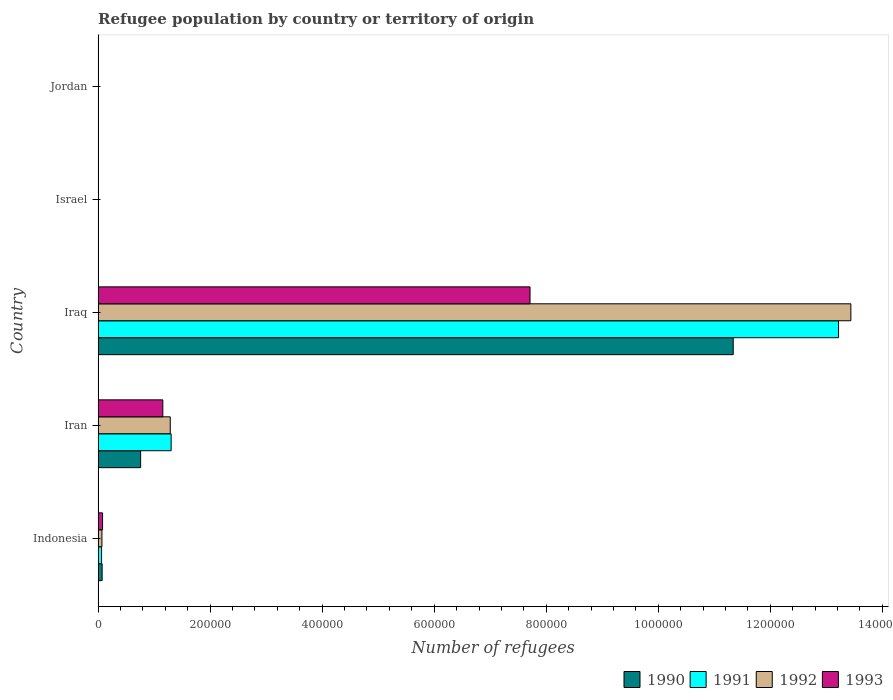How many groups of bars are there?
Offer a very short reply. 5. Are the number of bars per tick equal to the number of legend labels?
Provide a succinct answer. Yes. Are the number of bars on each tick of the Y-axis equal?
Provide a succinct answer. Yes. How many bars are there on the 3rd tick from the bottom?
Provide a short and direct response. 4. What is the label of the 2nd group of bars from the top?
Make the answer very short. Israel. What is the number of refugees in 1993 in Iraq?
Give a very brief answer. 7.71e+05. Across all countries, what is the maximum number of refugees in 1992?
Keep it short and to the point. 1.34e+06. Across all countries, what is the minimum number of refugees in 1990?
Make the answer very short. 16. In which country was the number of refugees in 1990 maximum?
Provide a short and direct response. Iraq. In which country was the number of refugees in 1990 minimum?
Offer a terse response. Israel. What is the total number of refugees in 1993 in the graph?
Your answer should be compact. 8.95e+05. What is the difference between the number of refugees in 1993 in Indonesia and that in Israel?
Provide a succinct answer. 7806. What is the difference between the number of refugees in 1991 in Jordan and the number of refugees in 1990 in Indonesia?
Ensure brevity in your answer.  -7057. What is the average number of refugees in 1992 per country?
Give a very brief answer. 2.96e+05. What is the difference between the number of refugees in 1992 and number of refugees in 1991 in Indonesia?
Ensure brevity in your answer.  665. In how many countries, is the number of refugees in 1992 greater than 360000 ?
Offer a very short reply. 1. What is the ratio of the number of refugees in 1993 in Israel to that in Jordan?
Your response must be concise. 0.49. Is the difference between the number of refugees in 1992 in Iran and Iraq greater than the difference between the number of refugees in 1991 in Iran and Iraq?
Ensure brevity in your answer.  No. What is the difference between the highest and the second highest number of refugees in 1990?
Offer a terse response. 1.06e+06. What is the difference between the highest and the lowest number of refugees in 1993?
Offer a terse response. 7.71e+05. Is the sum of the number of refugees in 1991 in Iraq and Israel greater than the maximum number of refugees in 1993 across all countries?
Your response must be concise. Yes. What does the 2nd bar from the top in Indonesia represents?
Keep it short and to the point. 1992. What does the 2nd bar from the bottom in Iran represents?
Offer a terse response. 1991. How many bars are there?
Offer a terse response. 20. Are all the bars in the graph horizontal?
Your answer should be compact. Yes. What is the difference between two consecutive major ticks on the X-axis?
Offer a very short reply. 2.00e+05. Are the values on the major ticks of X-axis written in scientific E-notation?
Give a very brief answer. No. How many legend labels are there?
Your response must be concise. 4. How are the legend labels stacked?
Offer a terse response. Horizontal. What is the title of the graph?
Offer a very short reply. Refugee population by country or territory of origin. What is the label or title of the X-axis?
Offer a terse response. Number of refugees. What is the label or title of the Y-axis?
Offer a terse response. Country. What is the Number of refugees in 1990 in Indonesia?
Provide a short and direct response. 7169. What is the Number of refugees of 1991 in Indonesia?
Keep it short and to the point. 6164. What is the Number of refugees in 1992 in Indonesia?
Make the answer very short. 6829. What is the Number of refugees in 1993 in Indonesia?
Your answer should be compact. 7924. What is the Number of refugees of 1990 in Iran?
Make the answer very short. 7.59e+04. What is the Number of refugees in 1991 in Iran?
Provide a succinct answer. 1.30e+05. What is the Number of refugees in 1992 in Iran?
Make the answer very short. 1.29e+05. What is the Number of refugees of 1993 in Iran?
Your answer should be compact. 1.16e+05. What is the Number of refugees of 1990 in Iraq?
Ensure brevity in your answer.  1.13e+06. What is the Number of refugees in 1991 in Iraq?
Make the answer very short. 1.32e+06. What is the Number of refugees of 1992 in Iraq?
Provide a short and direct response. 1.34e+06. What is the Number of refugees in 1993 in Iraq?
Offer a very short reply. 7.71e+05. What is the Number of refugees of 1990 in Israel?
Provide a short and direct response. 16. What is the Number of refugees of 1991 in Israel?
Your response must be concise. 28. What is the Number of refugees in 1993 in Israel?
Offer a terse response. 118. What is the Number of refugees of 1990 in Jordan?
Offer a terse response. 55. What is the Number of refugees in 1991 in Jordan?
Make the answer very short. 112. What is the Number of refugees of 1992 in Jordan?
Offer a very short reply. 183. What is the Number of refugees of 1993 in Jordan?
Provide a succinct answer. 242. Across all countries, what is the maximum Number of refugees in 1990?
Give a very brief answer. 1.13e+06. Across all countries, what is the maximum Number of refugees in 1991?
Provide a short and direct response. 1.32e+06. Across all countries, what is the maximum Number of refugees of 1992?
Your answer should be compact. 1.34e+06. Across all countries, what is the maximum Number of refugees of 1993?
Make the answer very short. 7.71e+05. Across all countries, what is the minimum Number of refugees in 1993?
Offer a very short reply. 118. What is the total Number of refugees in 1990 in the graph?
Your answer should be compact. 1.22e+06. What is the total Number of refugees of 1991 in the graph?
Keep it short and to the point. 1.46e+06. What is the total Number of refugees of 1992 in the graph?
Your answer should be compact. 1.48e+06. What is the total Number of refugees in 1993 in the graph?
Your response must be concise. 8.95e+05. What is the difference between the Number of refugees of 1990 in Indonesia and that in Iran?
Provide a succinct answer. -6.87e+04. What is the difference between the Number of refugees in 1991 in Indonesia and that in Iran?
Your answer should be compact. -1.24e+05. What is the difference between the Number of refugees in 1992 in Indonesia and that in Iran?
Your answer should be very brief. -1.22e+05. What is the difference between the Number of refugees in 1993 in Indonesia and that in Iran?
Keep it short and to the point. -1.08e+05. What is the difference between the Number of refugees of 1990 in Indonesia and that in Iraq?
Offer a very short reply. -1.13e+06. What is the difference between the Number of refugees of 1991 in Indonesia and that in Iraq?
Offer a terse response. -1.32e+06. What is the difference between the Number of refugees of 1992 in Indonesia and that in Iraq?
Offer a very short reply. -1.34e+06. What is the difference between the Number of refugees in 1993 in Indonesia and that in Iraq?
Your answer should be very brief. -7.63e+05. What is the difference between the Number of refugees in 1990 in Indonesia and that in Israel?
Provide a short and direct response. 7153. What is the difference between the Number of refugees of 1991 in Indonesia and that in Israel?
Your answer should be very brief. 6136. What is the difference between the Number of refugees of 1992 in Indonesia and that in Israel?
Offer a very short reply. 6789. What is the difference between the Number of refugees in 1993 in Indonesia and that in Israel?
Your answer should be compact. 7806. What is the difference between the Number of refugees of 1990 in Indonesia and that in Jordan?
Offer a terse response. 7114. What is the difference between the Number of refugees in 1991 in Indonesia and that in Jordan?
Offer a terse response. 6052. What is the difference between the Number of refugees of 1992 in Indonesia and that in Jordan?
Provide a succinct answer. 6646. What is the difference between the Number of refugees of 1993 in Indonesia and that in Jordan?
Keep it short and to the point. 7682. What is the difference between the Number of refugees of 1990 in Iran and that in Iraq?
Make the answer very short. -1.06e+06. What is the difference between the Number of refugees of 1991 in Iran and that in Iraq?
Provide a succinct answer. -1.19e+06. What is the difference between the Number of refugees in 1992 in Iran and that in Iraq?
Your response must be concise. -1.22e+06. What is the difference between the Number of refugees in 1993 in Iran and that in Iraq?
Offer a terse response. -6.56e+05. What is the difference between the Number of refugees in 1990 in Iran and that in Israel?
Your answer should be compact. 7.59e+04. What is the difference between the Number of refugees in 1991 in Iran and that in Israel?
Make the answer very short. 1.30e+05. What is the difference between the Number of refugees in 1992 in Iran and that in Israel?
Keep it short and to the point. 1.29e+05. What is the difference between the Number of refugees in 1993 in Iran and that in Israel?
Give a very brief answer. 1.15e+05. What is the difference between the Number of refugees of 1990 in Iran and that in Jordan?
Your answer should be very brief. 7.58e+04. What is the difference between the Number of refugees in 1991 in Iran and that in Jordan?
Ensure brevity in your answer.  1.30e+05. What is the difference between the Number of refugees of 1992 in Iran and that in Jordan?
Ensure brevity in your answer.  1.29e+05. What is the difference between the Number of refugees of 1993 in Iran and that in Jordan?
Keep it short and to the point. 1.15e+05. What is the difference between the Number of refugees in 1990 in Iraq and that in Israel?
Your response must be concise. 1.13e+06. What is the difference between the Number of refugees in 1991 in Iraq and that in Israel?
Your answer should be very brief. 1.32e+06. What is the difference between the Number of refugees in 1992 in Iraq and that in Israel?
Provide a succinct answer. 1.34e+06. What is the difference between the Number of refugees in 1993 in Iraq and that in Israel?
Your answer should be compact. 7.71e+05. What is the difference between the Number of refugees in 1990 in Iraq and that in Jordan?
Ensure brevity in your answer.  1.13e+06. What is the difference between the Number of refugees of 1991 in Iraq and that in Jordan?
Keep it short and to the point. 1.32e+06. What is the difference between the Number of refugees in 1992 in Iraq and that in Jordan?
Ensure brevity in your answer.  1.34e+06. What is the difference between the Number of refugees of 1993 in Iraq and that in Jordan?
Your answer should be very brief. 7.71e+05. What is the difference between the Number of refugees in 1990 in Israel and that in Jordan?
Keep it short and to the point. -39. What is the difference between the Number of refugees in 1991 in Israel and that in Jordan?
Provide a succinct answer. -84. What is the difference between the Number of refugees in 1992 in Israel and that in Jordan?
Provide a short and direct response. -143. What is the difference between the Number of refugees in 1993 in Israel and that in Jordan?
Your response must be concise. -124. What is the difference between the Number of refugees of 1990 in Indonesia and the Number of refugees of 1991 in Iran?
Offer a very short reply. -1.23e+05. What is the difference between the Number of refugees in 1990 in Indonesia and the Number of refugees in 1992 in Iran?
Provide a short and direct response. -1.22e+05. What is the difference between the Number of refugees in 1990 in Indonesia and the Number of refugees in 1993 in Iran?
Your answer should be very brief. -1.08e+05. What is the difference between the Number of refugees of 1991 in Indonesia and the Number of refugees of 1992 in Iran?
Give a very brief answer. -1.23e+05. What is the difference between the Number of refugees of 1991 in Indonesia and the Number of refugees of 1993 in Iran?
Offer a very short reply. -1.09e+05. What is the difference between the Number of refugees in 1992 in Indonesia and the Number of refugees in 1993 in Iran?
Keep it short and to the point. -1.09e+05. What is the difference between the Number of refugees in 1990 in Indonesia and the Number of refugees in 1991 in Iraq?
Keep it short and to the point. -1.31e+06. What is the difference between the Number of refugees of 1990 in Indonesia and the Number of refugees of 1992 in Iraq?
Offer a terse response. -1.34e+06. What is the difference between the Number of refugees of 1990 in Indonesia and the Number of refugees of 1993 in Iraq?
Offer a very short reply. -7.64e+05. What is the difference between the Number of refugees of 1991 in Indonesia and the Number of refugees of 1992 in Iraq?
Offer a very short reply. -1.34e+06. What is the difference between the Number of refugees of 1991 in Indonesia and the Number of refugees of 1993 in Iraq?
Offer a terse response. -7.65e+05. What is the difference between the Number of refugees of 1992 in Indonesia and the Number of refugees of 1993 in Iraq?
Make the answer very short. -7.64e+05. What is the difference between the Number of refugees in 1990 in Indonesia and the Number of refugees in 1991 in Israel?
Your answer should be very brief. 7141. What is the difference between the Number of refugees in 1990 in Indonesia and the Number of refugees in 1992 in Israel?
Ensure brevity in your answer.  7129. What is the difference between the Number of refugees of 1990 in Indonesia and the Number of refugees of 1993 in Israel?
Keep it short and to the point. 7051. What is the difference between the Number of refugees of 1991 in Indonesia and the Number of refugees of 1992 in Israel?
Provide a succinct answer. 6124. What is the difference between the Number of refugees in 1991 in Indonesia and the Number of refugees in 1993 in Israel?
Provide a short and direct response. 6046. What is the difference between the Number of refugees of 1992 in Indonesia and the Number of refugees of 1993 in Israel?
Ensure brevity in your answer.  6711. What is the difference between the Number of refugees of 1990 in Indonesia and the Number of refugees of 1991 in Jordan?
Provide a short and direct response. 7057. What is the difference between the Number of refugees of 1990 in Indonesia and the Number of refugees of 1992 in Jordan?
Keep it short and to the point. 6986. What is the difference between the Number of refugees of 1990 in Indonesia and the Number of refugees of 1993 in Jordan?
Your answer should be compact. 6927. What is the difference between the Number of refugees in 1991 in Indonesia and the Number of refugees in 1992 in Jordan?
Give a very brief answer. 5981. What is the difference between the Number of refugees of 1991 in Indonesia and the Number of refugees of 1993 in Jordan?
Make the answer very short. 5922. What is the difference between the Number of refugees in 1992 in Indonesia and the Number of refugees in 1993 in Jordan?
Give a very brief answer. 6587. What is the difference between the Number of refugees in 1990 in Iran and the Number of refugees in 1991 in Iraq?
Your answer should be compact. -1.25e+06. What is the difference between the Number of refugees of 1990 in Iran and the Number of refugees of 1992 in Iraq?
Provide a succinct answer. -1.27e+06. What is the difference between the Number of refugees of 1990 in Iran and the Number of refugees of 1993 in Iraq?
Offer a very short reply. -6.95e+05. What is the difference between the Number of refugees in 1991 in Iran and the Number of refugees in 1992 in Iraq?
Provide a short and direct response. -1.21e+06. What is the difference between the Number of refugees in 1991 in Iran and the Number of refugees in 1993 in Iraq?
Provide a succinct answer. -6.41e+05. What is the difference between the Number of refugees in 1992 in Iran and the Number of refugees in 1993 in Iraq?
Provide a succinct answer. -6.42e+05. What is the difference between the Number of refugees in 1990 in Iran and the Number of refugees in 1991 in Israel?
Ensure brevity in your answer.  7.59e+04. What is the difference between the Number of refugees of 1990 in Iran and the Number of refugees of 1992 in Israel?
Your answer should be very brief. 7.58e+04. What is the difference between the Number of refugees of 1990 in Iran and the Number of refugees of 1993 in Israel?
Ensure brevity in your answer.  7.58e+04. What is the difference between the Number of refugees in 1991 in Iran and the Number of refugees in 1992 in Israel?
Your response must be concise. 1.30e+05. What is the difference between the Number of refugees of 1991 in Iran and the Number of refugees of 1993 in Israel?
Ensure brevity in your answer.  1.30e+05. What is the difference between the Number of refugees of 1992 in Iran and the Number of refugees of 1993 in Israel?
Your answer should be compact. 1.29e+05. What is the difference between the Number of refugees in 1990 in Iran and the Number of refugees in 1991 in Jordan?
Give a very brief answer. 7.58e+04. What is the difference between the Number of refugees of 1990 in Iran and the Number of refugees of 1992 in Jordan?
Keep it short and to the point. 7.57e+04. What is the difference between the Number of refugees of 1990 in Iran and the Number of refugees of 1993 in Jordan?
Keep it short and to the point. 7.56e+04. What is the difference between the Number of refugees of 1991 in Iran and the Number of refugees of 1992 in Jordan?
Give a very brief answer. 1.30e+05. What is the difference between the Number of refugees in 1991 in Iran and the Number of refugees in 1993 in Jordan?
Keep it short and to the point. 1.30e+05. What is the difference between the Number of refugees of 1992 in Iran and the Number of refugees of 1993 in Jordan?
Give a very brief answer. 1.29e+05. What is the difference between the Number of refugees in 1990 in Iraq and the Number of refugees in 1991 in Israel?
Provide a short and direct response. 1.13e+06. What is the difference between the Number of refugees in 1990 in Iraq and the Number of refugees in 1992 in Israel?
Your answer should be very brief. 1.13e+06. What is the difference between the Number of refugees in 1990 in Iraq and the Number of refugees in 1993 in Israel?
Make the answer very short. 1.13e+06. What is the difference between the Number of refugees of 1991 in Iraq and the Number of refugees of 1992 in Israel?
Your response must be concise. 1.32e+06. What is the difference between the Number of refugees of 1991 in Iraq and the Number of refugees of 1993 in Israel?
Offer a terse response. 1.32e+06. What is the difference between the Number of refugees of 1992 in Iraq and the Number of refugees of 1993 in Israel?
Make the answer very short. 1.34e+06. What is the difference between the Number of refugees in 1990 in Iraq and the Number of refugees in 1991 in Jordan?
Offer a terse response. 1.13e+06. What is the difference between the Number of refugees of 1990 in Iraq and the Number of refugees of 1992 in Jordan?
Provide a succinct answer. 1.13e+06. What is the difference between the Number of refugees in 1990 in Iraq and the Number of refugees in 1993 in Jordan?
Your answer should be compact. 1.13e+06. What is the difference between the Number of refugees in 1991 in Iraq and the Number of refugees in 1992 in Jordan?
Make the answer very short. 1.32e+06. What is the difference between the Number of refugees of 1991 in Iraq and the Number of refugees of 1993 in Jordan?
Give a very brief answer. 1.32e+06. What is the difference between the Number of refugees of 1992 in Iraq and the Number of refugees of 1993 in Jordan?
Provide a succinct answer. 1.34e+06. What is the difference between the Number of refugees of 1990 in Israel and the Number of refugees of 1991 in Jordan?
Your answer should be very brief. -96. What is the difference between the Number of refugees in 1990 in Israel and the Number of refugees in 1992 in Jordan?
Your answer should be very brief. -167. What is the difference between the Number of refugees in 1990 in Israel and the Number of refugees in 1993 in Jordan?
Offer a very short reply. -226. What is the difference between the Number of refugees in 1991 in Israel and the Number of refugees in 1992 in Jordan?
Provide a short and direct response. -155. What is the difference between the Number of refugees of 1991 in Israel and the Number of refugees of 1993 in Jordan?
Your response must be concise. -214. What is the difference between the Number of refugees of 1992 in Israel and the Number of refugees of 1993 in Jordan?
Give a very brief answer. -202. What is the average Number of refugees of 1990 per country?
Give a very brief answer. 2.43e+05. What is the average Number of refugees of 1991 per country?
Ensure brevity in your answer.  2.92e+05. What is the average Number of refugees in 1992 per country?
Make the answer very short. 2.96e+05. What is the average Number of refugees of 1993 per country?
Give a very brief answer. 1.79e+05. What is the difference between the Number of refugees in 1990 and Number of refugees in 1991 in Indonesia?
Make the answer very short. 1005. What is the difference between the Number of refugees in 1990 and Number of refugees in 1992 in Indonesia?
Your answer should be compact. 340. What is the difference between the Number of refugees of 1990 and Number of refugees of 1993 in Indonesia?
Give a very brief answer. -755. What is the difference between the Number of refugees of 1991 and Number of refugees of 1992 in Indonesia?
Make the answer very short. -665. What is the difference between the Number of refugees in 1991 and Number of refugees in 1993 in Indonesia?
Your answer should be very brief. -1760. What is the difference between the Number of refugees of 1992 and Number of refugees of 1993 in Indonesia?
Ensure brevity in your answer.  -1095. What is the difference between the Number of refugees of 1990 and Number of refugees of 1991 in Iran?
Make the answer very short. -5.45e+04. What is the difference between the Number of refugees in 1990 and Number of refugees in 1992 in Iran?
Make the answer very short. -5.29e+04. What is the difference between the Number of refugees of 1990 and Number of refugees of 1993 in Iran?
Offer a very short reply. -3.96e+04. What is the difference between the Number of refugees in 1991 and Number of refugees in 1992 in Iran?
Offer a very short reply. 1585. What is the difference between the Number of refugees in 1991 and Number of refugees in 1993 in Iran?
Make the answer very short. 1.48e+04. What is the difference between the Number of refugees of 1992 and Number of refugees of 1993 in Iran?
Provide a succinct answer. 1.33e+04. What is the difference between the Number of refugees of 1990 and Number of refugees of 1991 in Iraq?
Keep it short and to the point. -1.88e+05. What is the difference between the Number of refugees in 1990 and Number of refugees in 1992 in Iraq?
Your response must be concise. -2.10e+05. What is the difference between the Number of refugees of 1990 and Number of refugees of 1993 in Iraq?
Ensure brevity in your answer.  3.63e+05. What is the difference between the Number of refugees in 1991 and Number of refugees in 1992 in Iraq?
Provide a succinct answer. -2.20e+04. What is the difference between the Number of refugees in 1991 and Number of refugees in 1993 in Iraq?
Make the answer very short. 5.51e+05. What is the difference between the Number of refugees in 1992 and Number of refugees in 1993 in Iraq?
Offer a very short reply. 5.73e+05. What is the difference between the Number of refugees in 1990 and Number of refugees in 1993 in Israel?
Offer a very short reply. -102. What is the difference between the Number of refugees in 1991 and Number of refugees in 1993 in Israel?
Make the answer very short. -90. What is the difference between the Number of refugees of 1992 and Number of refugees of 1993 in Israel?
Ensure brevity in your answer.  -78. What is the difference between the Number of refugees in 1990 and Number of refugees in 1991 in Jordan?
Your answer should be very brief. -57. What is the difference between the Number of refugees in 1990 and Number of refugees in 1992 in Jordan?
Offer a terse response. -128. What is the difference between the Number of refugees of 1990 and Number of refugees of 1993 in Jordan?
Give a very brief answer. -187. What is the difference between the Number of refugees in 1991 and Number of refugees in 1992 in Jordan?
Offer a terse response. -71. What is the difference between the Number of refugees of 1991 and Number of refugees of 1993 in Jordan?
Your answer should be very brief. -130. What is the difference between the Number of refugees in 1992 and Number of refugees in 1993 in Jordan?
Your response must be concise. -59. What is the ratio of the Number of refugees of 1990 in Indonesia to that in Iran?
Ensure brevity in your answer.  0.09. What is the ratio of the Number of refugees in 1991 in Indonesia to that in Iran?
Your answer should be compact. 0.05. What is the ratio of the Number of refugees in 1992 in Indonesia to that in Iran?
Your response must be concise. 0.05. What is the ratio of the Number of refugees in 1993 in Indonesia to that in Iran?
Provide a succinct answer. 0.07. What is the ratio of the Number of refugees of 1990 in Indonesia to that in Iraq?
Offer a terse response. 0.01. What is the ratio of the Number of refugees of 1991 in Indonesia to that in Iraq?
Offer a very short reply. 0. What is the ratio of the Number of refugees of 1992 in Indonesia to that in Iraq?
Provide a succinct answer. 0.01. What is the ratio of the Number of refugees in 1993 in Indonesia to that in Iraq?
Your response must be concise. 0.01. What is the ratio of the Number of refugees in 1990 in Indonesia to that in Israel?
Your answer should be very brief. 448.06. What is the ratio of the Number of refugees in 1991 in Indonesia to that in Israel?
Provide a succinct answer. 220.14. What is the ratio of the Number of refugees in 1992 in Indonesia to that in Israel?
Give a very brief answer. 170.72. What is the ratio of the Number of refugees in 1993 in Indonesia to that in Israel?
Your response must be concise. 67.15. What is the ratio of the Number of refugees of 1990 in Indonesia to that in Jordan?
Make the answer very short. 130.35. What is the ratio of the Number of refugees of 1991 in Indonesia to that in Jordan?
Offer a very short reply. 55.04. What is the ratio of the Number of refugees in 1992 in Indonesia to that in Jordan?
Provide a short and direct response. 37.32. What is the ratio of the Number of refugees of 1993 in Indonesia to that in Jordan?
Your answer should be very brief. 32.74. What is the ratio of the Number of refugees of 1990 in Iran to that in Iraq?
Give a very brief answer. 0.07. What is the ratio of the Number of refugees in 1991 in Iran to that in Iraq?
Provide a short and direct response. 0.1. What is the ratio of the Number of refugees of 1992 in Iran to that in Iraq?
Make the answer very short. 0.1. What is the ratio of the Number of refugees of 1993 in Iran to that in Iraq?
Offer a very short reply. 0.15. What is the ratio of the Number of refugees of 1990 in Iran to that in Israel?
Give a very brief answer. 4743.06. What is the ratio of the Number of refugees of 1991 in Iran to that in Israel?
Your answer should be compact. 4655.93. What is the ratio of the Number of refugees of 1992 in Iran to that in Israel?
Offer a very short reply. 3219.53. What is the ratio of the Number of refugees in 1993 in Iran to that in Israel?
Your response must be concise. 979.01. What is the ratio of the Number of refugees in 1990 in Iran to that in Jordan?
Keep it short and to the point. 1379.8. What is the ratio of the Number of refugees of 1991 in Iran to that in Jordan?
Provide a short and direct response. 1163.98. What is the ratio of the Number of refugees in 1992 in Iran to that in Jordan?
Offer a terse response. 703.72. What is the ratio of the Number of refugees in 1993 in Iran to that in Jordan?
Offer a very short reply. 477.37. What is the ratio of the Number of refugees in 1990 in Iraq to that in Israel?
Your answer should be compact. 7.09e+04. What is the ratio of the Number of refugees of 1991 in Iraq to that in Israel?
Ensure brevity in your answer.  4.72e+04. What is the ratio of the Number of refugees in 1992 in Iraq to that in Israel?
Ensure brevity in your answer.  3.36e+04. What is the ratio of the Number of refugees in 1993 in Iraq to that in Israel?
Make the answer very short. 6534.55. What is the ratio of the Number of refugees in 1990 in Iraq to that in Jordan?
Keep it short and to the point. 2.06e+04. What is the ratio of the Number of refugees in 1991 in Iraq to that in Jordan?
Offer a very short reply. 1.18e+04. What is the ratio of the Number of refugees of 1992 in Iraq to that in Jordan?
Offer a terse response. 7343.3. What is the ratio of the Number of refugees in 1993 in Iraq to that in Jordan?
Your response must be concise. 3186.27. What is the ratio of the Number of refugees of 1990 in Israel to that in Jordan?
Make the answer very short. 0.29. What is the ratio of the Number of refugees in 1992 in Israel to that in Jordan?
Provide a short and direct response. 0.22. What is the ratio of the Number of refugees in 1993 in Israel to that in Jordan?
Make the answer very short. 0.49. What is the difference between the highest and the second highest Number of refugees of 1990?
Provide a succinct answer. 1.06e+06. What is the difference between the highest and the second highest Number of refugees of 1991?
Provide a short and direct response. 1.19e+06. What is the difference between the highest and the second highest Number of refugees of 1992?
Your response must be concise. 1.22e+06. What is the difference between the highest and the second highest Number of refugees of 1993?
Offer a very short reply. 6.56e+05. What is the difference between the highest and the lowest Number of refugees in 1990?
Keep it short and to the point. 1.13e+06. What is the difference between the highest and the lowest Number of refugees in 1991?
Provide a short and direct response. 1.32e+06. What is the difference between the highest and the lowest Number of refugees in 1992?
Your answer should be very brief. 1.34e+06. What is the difference between the highest and the lowest Number of refugees in 1993?
Your response must be concise. 7.71e+05. 